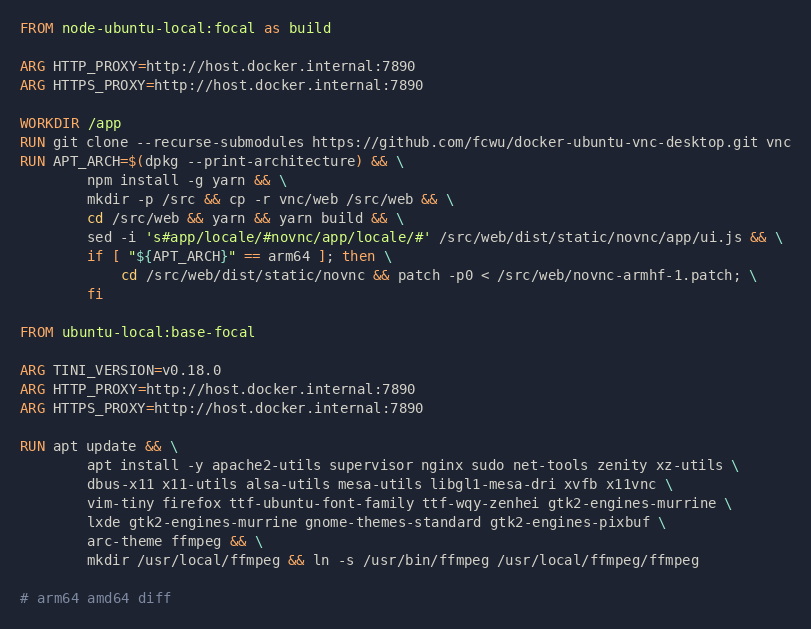Convert code to text. <code><loc_0><loc_0><loc_500><loc_500><_Dockerfile_>FROM node-ubuntu-local:focal as build

ARG HTTP_PROXY=http://host.docker.internal:7890
ARG HTTPS_PROXY=http://host.docker.internal:7890

WORKDIR /app
RUN git clone --recurse-submodules https://github.com/fcwu/docker-ubuntu-vnc-desktop.git vnc
RUN APT_ARCH=$(dpkg --print-architecture) && \
        npm install -g yarn && \
        mkdir -p /src && cp -r vnc/web /src/web && \
        cd /src/web && yarn && yarn build && \
        sed -i 's#app/locale/#novnc/app/locale/#' /src/web/dist/static/novnc/app/ui.js && \
        if [ "${APT_ARCH}" == arm64 ]; then \
            cd /src/web/dist/static/novnc && patch -p0 < /src/web/novnc-armhf-1.patch; \
        fi

FROM ubuntu-local:base-focal

ARG TINI_VERSION=v0.18.0
ARG HTTP_PROXY=http://host.docker.internal:7890
ARG HTTPS_PROXY=http://host.docker.internal:7890

RUN apt update && \
        apt install -y apache2-utils supervisor nginx sudo net-tools zenity xz-utils \
        dbus-x11 x11-utils alsa-utils mesa-utils libgl1-mesa-dri xvfb x11vnc \
        vim-tiny firefox ttf-ubuntu-font-family ttf-wqy-zenhei gtk2-engines-murrine \
        lxde gtk2-engines-murrine gnome-themes-standard gtk2-engines-pixbuf \
        arc-theme ffmpeg && \
        mkdir /usr/local/ffmpeg && ln -s /usr/bin/ffmpeg /usr/local/ffmpeg/ffmpeg

# arm64 amd64 diff</code> 